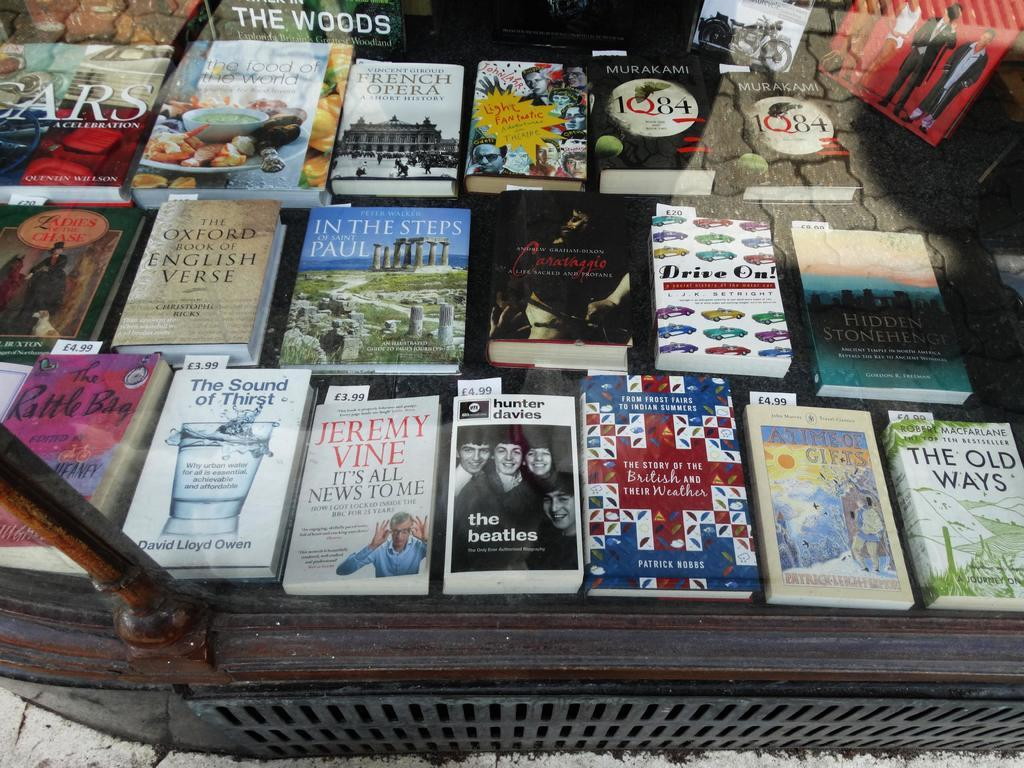Provide a one-sentence caption for the provided image. A book called The Old Ways among many books on a table. 